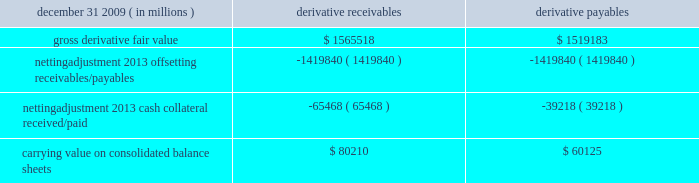Jpmorgan chase & co./2009 annual report 181 the table shows the current credit risk of derivative receivables after netting adjustments , and the current liquidity risk of derivative payables after netting adjustments , as of december 31 , 2009. .
In addition to the collateral amounts reflected in the table above , at december 31 , 2009 , the firm had received and posted liquid secu- rities collateral in the amount of $ 15.5 billion and $ 11.7 billion , respectively .
The firm also receives and delivers collateral at the initiation of derivative transactions , which is available as security against potential exposure that could arise should the fair value of the transactions move in the firm 2019s or client 2019s favor , respectively .
Furthermore , the firm and its counterparties hold collateral related to contracts that have a non-daily call frequency for collateral to be posted , and collateral that the firm or a counterparty has agreed to return but has not yet settled as of the reporting date .
At december 31 , 2009 , the firm had received $ 16.9 billion and delivered $ 5.8 billion of such additional collateral .
These amounts were not netted against the derivative receivables and payables in the table above , because , at an individual counterparty level , the collateral exceeded the fair value exposure at december 31 , 2009 .
Credit derivatives credit derivatives are financial instruments whose value is derived from the credit risk associated with the debt of a third-party issuer ( the reference entity ) and which allow one party ( the protection purchaser ) to transfer that risk to another party ( the protection seller ) .
Credit derivatives expose the protection purchaser to the creditworthiness of the protection seller , as the protection seller is required to make payments under the contract when the reference entity experiences a credit event , such as a bankruptcy , a failure to pay its obligation or a restructuring .
The seller of credit protection receives a premium for providing protection but has the risk that the underlying instrument referenced in the contract will be subject to a credit event .
The firm is both a purchaser and seller of protection in the credit derivatives market and uses these derivatives for two primary purposes .
First , in its capacity as a market-maker in the dealer/client business , the firm actively risk manages a portfolio of credit derivatives by purchasing and selling credit protection , pre- dominantly on corporate debt obligations , to meet the needs of customers .
As a seller of protection , the firm 2019s exposure to a given reference entity may be offset partially , or entirely , with a contract to purchase protection from another counterparty on the same or similar reference entity .
Second , the firm uses credit derivatives to mitigate credit risk associated with its overall derivative receivables and traditional commercial credit lending exposures ( loans and unfunded commitments ) as well as to manage its exposure to residential and commercial mortgages .
See note 3 on pages 156--- 173 of this annual report for further information on the firm 2019s mortgage-related exposures .
In accomplishing the above , the firm uses different types of credit derivatives .
Following is a summary of various types of credit derivatives .
Credit default swaps credit derivatives may reference the credit of either a single refer- ence entity ( 201csingle-name 201d ) or a broad-based index , as described further below .
The firm purchases and sells protection on both single- name and index-reference obligations .
Single-name cds and index cds contracts are both otc derivative contracts .
Single- name cds are used to manage the default risk of a single reference entity , while cds index are used to manage credit risk associated with the broader credit markets or credit market segments .
Like the s&p 500 and other market indices , a cds index is comprised of a portfolio of cds across many reference entities .
New series of cds indices are established approximately every six months with a new underlying portfolio of reference entities to reflect changes in the credit markets .
If one of the reference entities in the index experi- ences a credit event , then the reference entity that defaulted is removed from the index .
Cds can also be referenced against spe- cific portfolios of reference names or against customized exposure levels based on specific client demands : for example , to provide protection against the first $ 1 million of realized credit losses in a $ 10 million portfolio of exposure .
Such structures are commonly known as tranche cds .
For both single-name cds contracts and index cds , upon the occurrence of a credit event , under the terms of a cds contract neither party to the cds contract has recourse to the reference entity .
The protection purchaser has recourse to the protection seller for the difference between the face value of the cds contract and the fair value of the reference obligation at the time of settling the credit derivative contract , also known as the recovery value .
The protection purchaser does not need to hold the debt instrument of the underlying reference entity in order to receive amounts due under the cds contract when a credit event occurs .
Credit-linked notes a credit linked note ( 201ccln 201d ) is a funded credit derivative where the issuer of the cln purchases credit protection on a referenced entity from the note investor .
Under the contract , the investor pays the issuer par value of the note at the inception of the transaction , and in return , the issuer pays periodic payments to the investor , based on the credit risk of the referenced entity .
The issuer also repays the investor the par value of the note at maturity unless the reference entity experiences a specified credit event .
In that event , the issuer is not obligated to repay the par value of the note , but rather , the issuer pays the investor the difference between the par value of the note .
In 2009 what was the ratio of the gross derivative fair value recievables to the payables? 
Computations: (1565518 / 1519183)
Answer: 1.0305. 